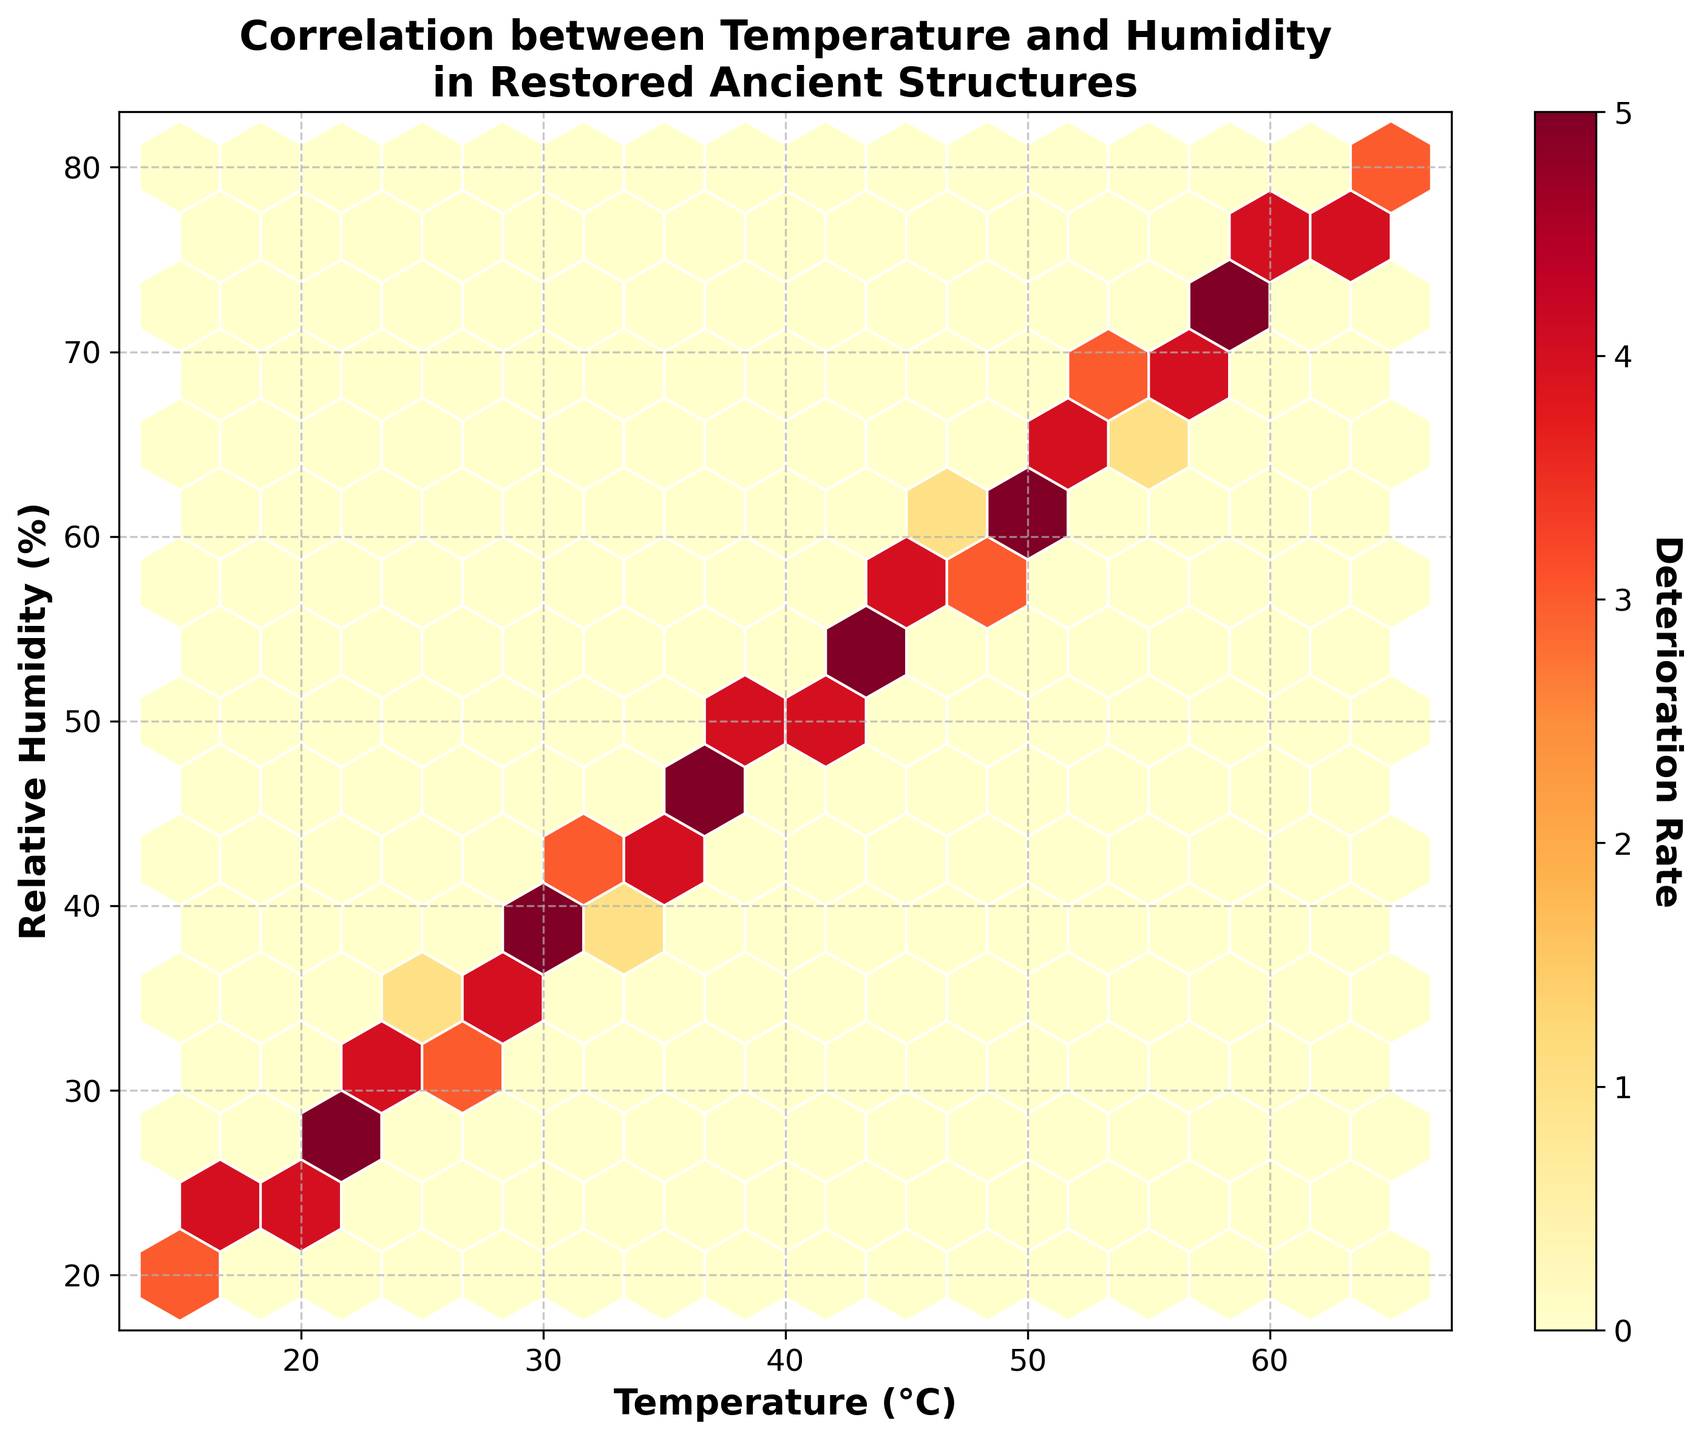What is the title of the plot? The title of the plot is displayed at the top of the figure. It reads 'Correlation between Temperature and Humidity in Restored Ancient Structures'.
Answer: Correlation between Temperature and Humidity in Restored Ancient Structures What do the axes labels represent? The x-axis label is 'Temperature (°C)' which represents temperature in degrees Celsius, and the y-axis label is 'Relative Humidity (%)' which represents relative humidity in percentage.
Answer: Temperature (°C), Relative Humidity (%) What does the color represent in the hexbin plot? The color in the hexbin plot represents the deterioration rate, as indicated by the colorbar on the right side of the plot.
Answer: Deterioration Rate What is the data range for the Temperature (°C) axis? The x-axis label 'Temperature (°C)' shows the range of temperature from 15°C to 65°C.
Answer: 15°C to 65°C What is the data range for the Relative Humidity (%) axis? The y-axis label 'Relative Humidity (%)' shows the range of relative humidity from 20% to 80%.
Answer: 20% to 80% Which area shows the highest deterioration rate? To identify the areas with the highest deterioration rate, look for the hexagons with the darkest color in the colorbar (YlOrRd color scheme).
Answer: Central-right part of the plot Is there a noticeable trend between temperature and relative humidity? By observing the distribution of the hexbin pattern and the color gradient, we can assess the relationship between temperature and relative humidity. If the hexagons consistently become darker at higher ranges, there may be a positive correlation.
Answer: Yes, a positive correlation At approximately what Temperature and Humidity value does the deterioration rate peak? The hexbin with the darkest shade indicates the peak deterioration rate. This can be observed by cross-referencing the approximate coordinates in the x-axis and y-axis.
Answer: Around 60°C and 70% Which color segment in the plot indicates the lowest deterioration rate? Refer to the colorbar and identify the lightest color (in the scale of YlOrRd) corresponding to low deterioration rates.
Answer: Light yellow Can you determine any clusters from the plot? Clusters can be identified by observing densely packed hexagons of similar colors. This can indicate areas where temperature and humidity values are concentrated.
Answer: Yes, multiple clusters 